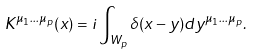<formula> <loc_0><loc_0><loc_500><loc_500>K ^ { \mu _ { 1 } \dots \mu _ { p } } ( x ) = i \int _ { W _ { p } } \delta ( x - y ) d y ^ { \mu _ { 1 } \dots \mu _ { p } } .</formula> 